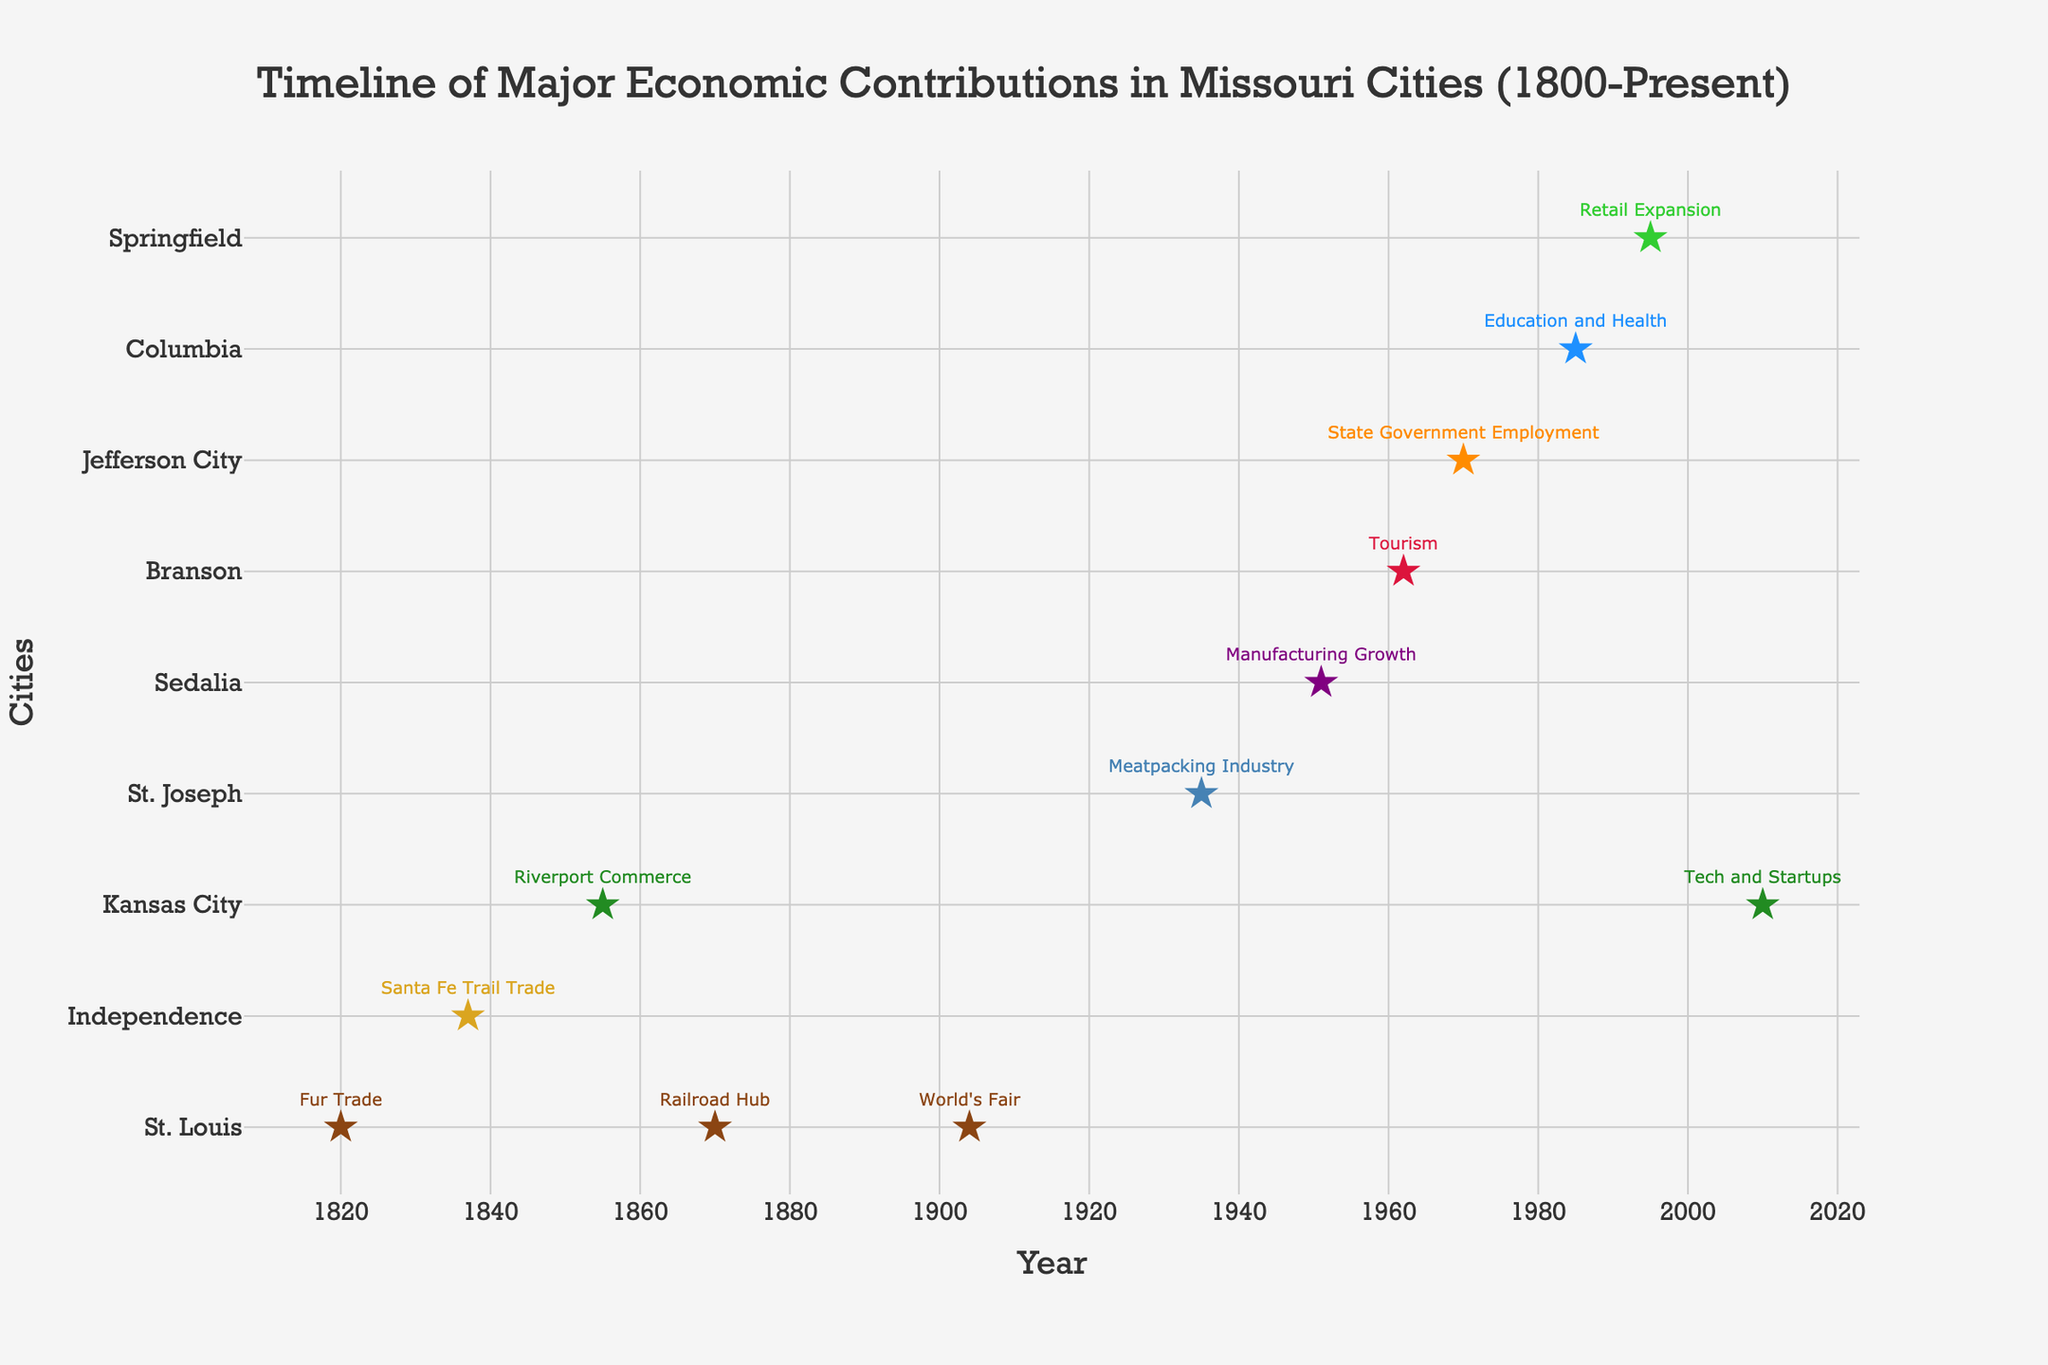What is the major economic contribution of St. Louis in 1904? Looking at the timeline, we see that in 1904, St. Louis is associated with "World's Fair" as its major economic contribution.
Answer: World's Fair Which city had a significant economic contribution related to the fur trade? The plot shows that St. Louis had the fur trade as a major economic contribution in the year 1820.
Answer: St. Louis What are the years that show major economic contributions for Kansas City? The plot shows data points for Kansas City at 1855 and 2010.
Answer: 1855, 2010 How many cities had major economic contributions before the 1900s? Counting the cities with contributions listed before 1900, we see St. Louis (1820, 1870), Independence (1837), and Kansas City (1855).
Answer: Three Which city’s economic contribution included an event that boosted the local economy and when did it happen? St. Louis had a significant economic boost due to the World's Fair in 1904.
Answer: St. Louis, 1904 Compare the economic contributions of Jefferson City and Columbia. Which year did each city have its major contribution? Jefferson City's major contribution was "State Government Employment" in 1970, while Columbia's was "Education and Health" in 1985.
Answer: 1970, 1985 What is the most recent major economic contribution listed for Missouri cities? The most recent year on the timeline is 2010 with Kansas City's contribution to Tech and Startups.
Answer: 2010 Which city saw a surge in tourism and in what year did this occur? The plot indicates Branson experienced a surge in tourism in 1962.
Answer: Branson, 1962 Arrange the cities based on the timeline of their first listed major economic contribution. Sorting the cities by the year of their first economic contribution: St. Louis (1820), Independence (1837), Kansas City (1855), St. Joseph (1935), Sedalia (1951), Branson (1962), Jefferson City (1970), Columbia (1985), Springfield (1995).
Answer: St. Louis, Independence, Kansas City, St. Joseph, Sedalia, Branson, Jefferson City, Columbia, Springfield Which city contributed to manufacturing growth and in which year? The plot shows Sedalia had manufacturing growth in 1951.
Answer: Sedalia, 1951 